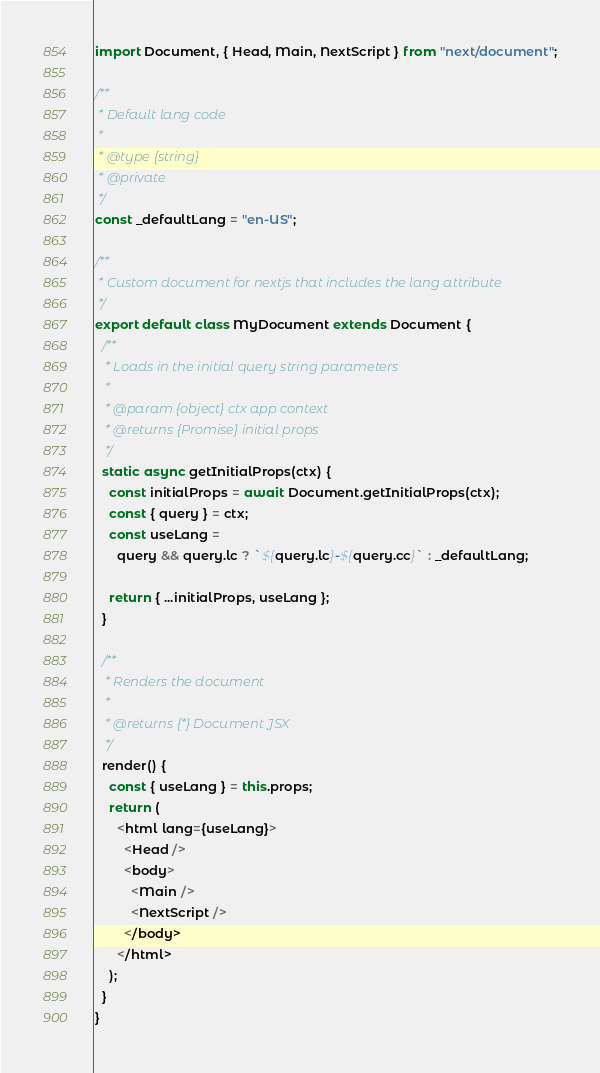<code> <loc_0><loc_0><loc_500><loc_500><_JavaScript_>import Document, { Head, Main, NextScript } from "next/document";

/**
 * Default lang code
 *
 * @type {string}
 * @private
 */
const _defaultLang = "en-US";

/**
 * Custom document for nextjs that includes the lang attribute
 */
export default class MyDocument extends Document {
  /**
   * Loads in the initial query string parameters
   *
   * @param {object} ctx app context
   * @returns {Promise} initial props
   */
  static async getInitialProps(ctx) {
    const initialProps = await Document.getInitialProps(ctx);
    const { query } = ctx;
    const useLang =
      query && query.lc ? `${query.lc}-${query.cc}` : _defaultLang;

    return { ...initialProps, useLang };
  }

  /**
   * Renders the document
   *
   * @returns {*} Document JSX
   */
  render() {
    const { useLang } = this.props;
    return (
      <html lang={useLang}>
        <Head />
        <body>
          <Main />
          <NextScript />
        </body>
      </html>
    );
  }
}
</code> 